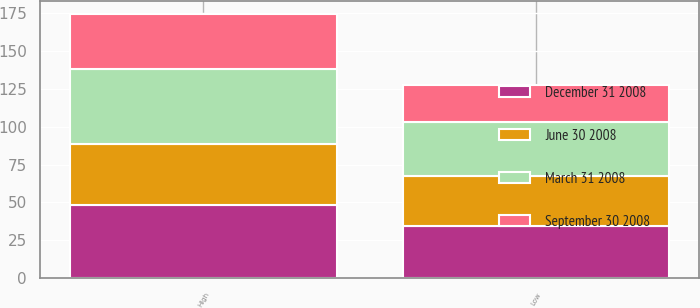Convert chart. <chart><loc_0><loc_0><loc_500><loc_500><stacked_bar_chart><ecel><fcel>High<fcel>Low<nl><fcel>September 30 2008<fcel>36.61<fcel>24.1<nl><fcel>December 31 2008<fcel>48.46<fcel>34.6<nl><fcel>March 31 2008<fcel>49.15<fcel>35.47<nl><fcel>June 30 2008<fcel>40.37<fcel>33.06<nl></chart> 